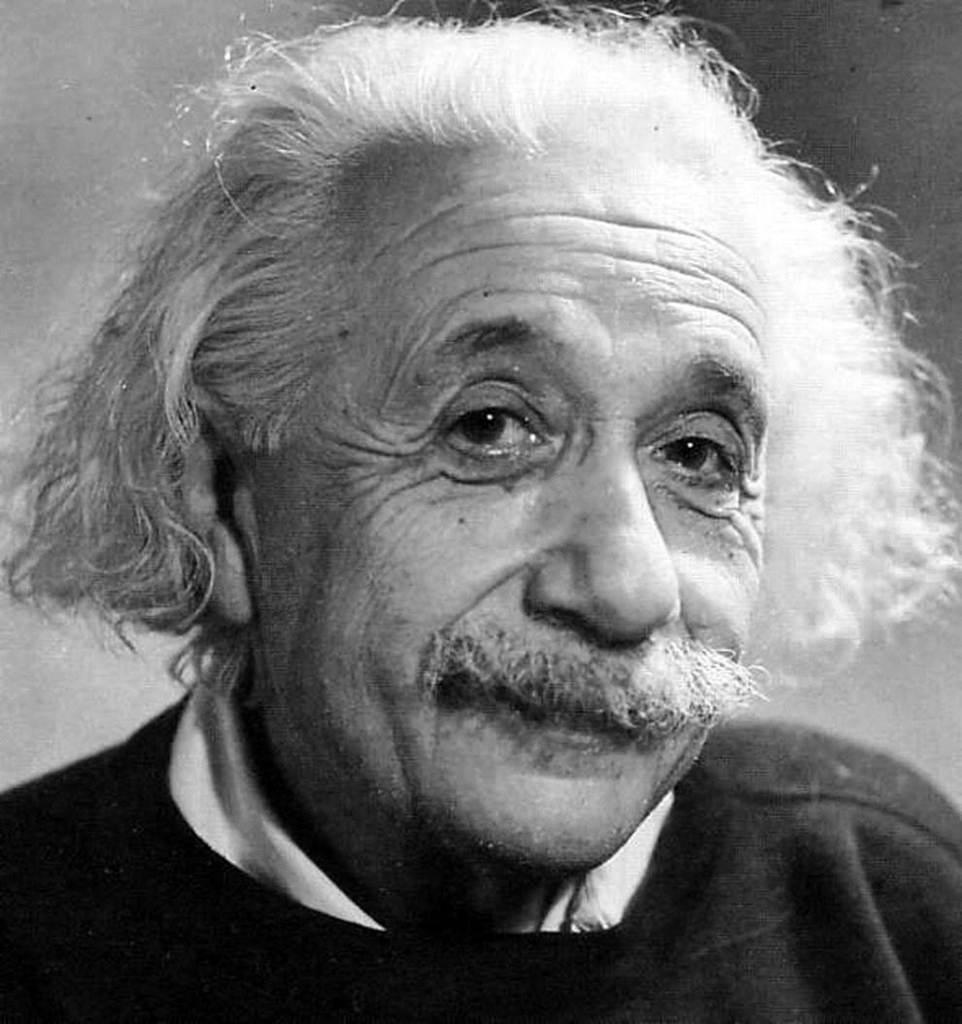What is the image is in color or black and white? The image is black and white. What is the main subject of the image? There is a man in the center of the image. How many crows are perched on the ship in the image? There is no ship or crow present in the image; it features a man in the center of a black and white image. What type of spade is the man holding in the image? There is no spade present in the image; it only features a man in the center of a black and white image. 